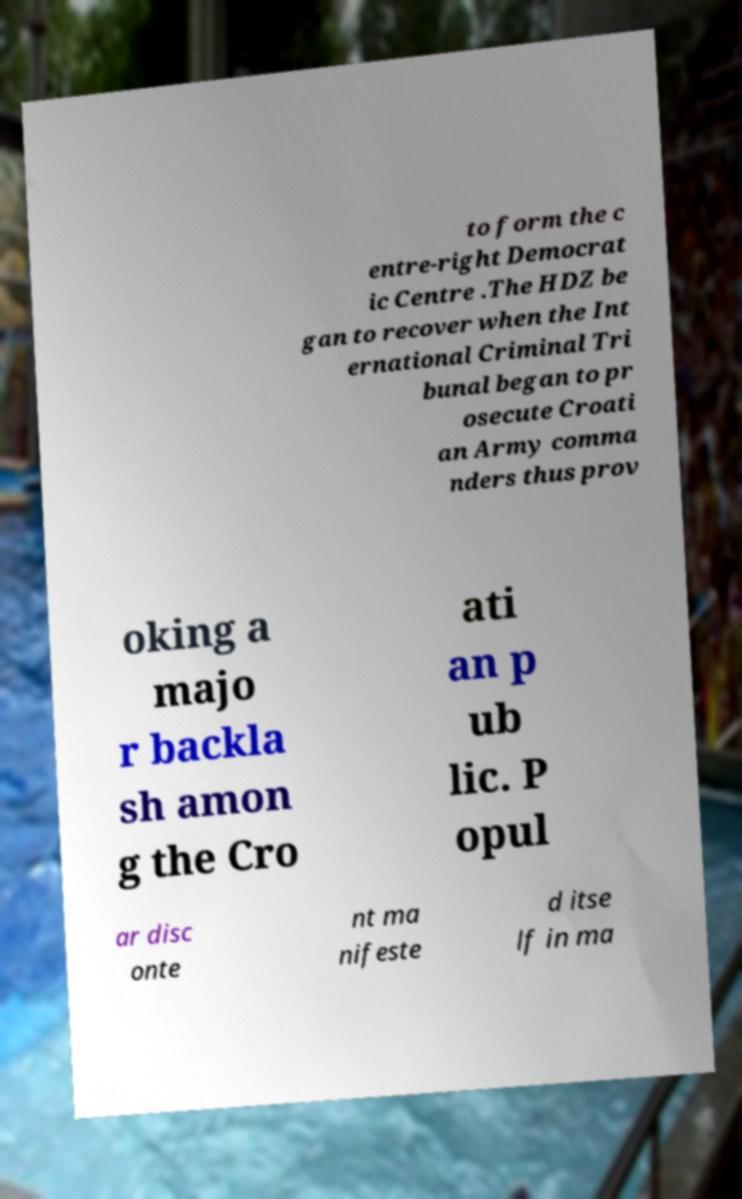Could you extract and type out the text from this image? to form the c entre-right Democrat ic Centre .The HDZ be gan to recover when the Int ernational Criminal Tri bunal began to pr osecute Croati an Army comma nders thus prov oking a majo r backla sh amon g the Cro ati an p ub lic. P opul ar disc onte nt ma nifeste d itse lf in ma 